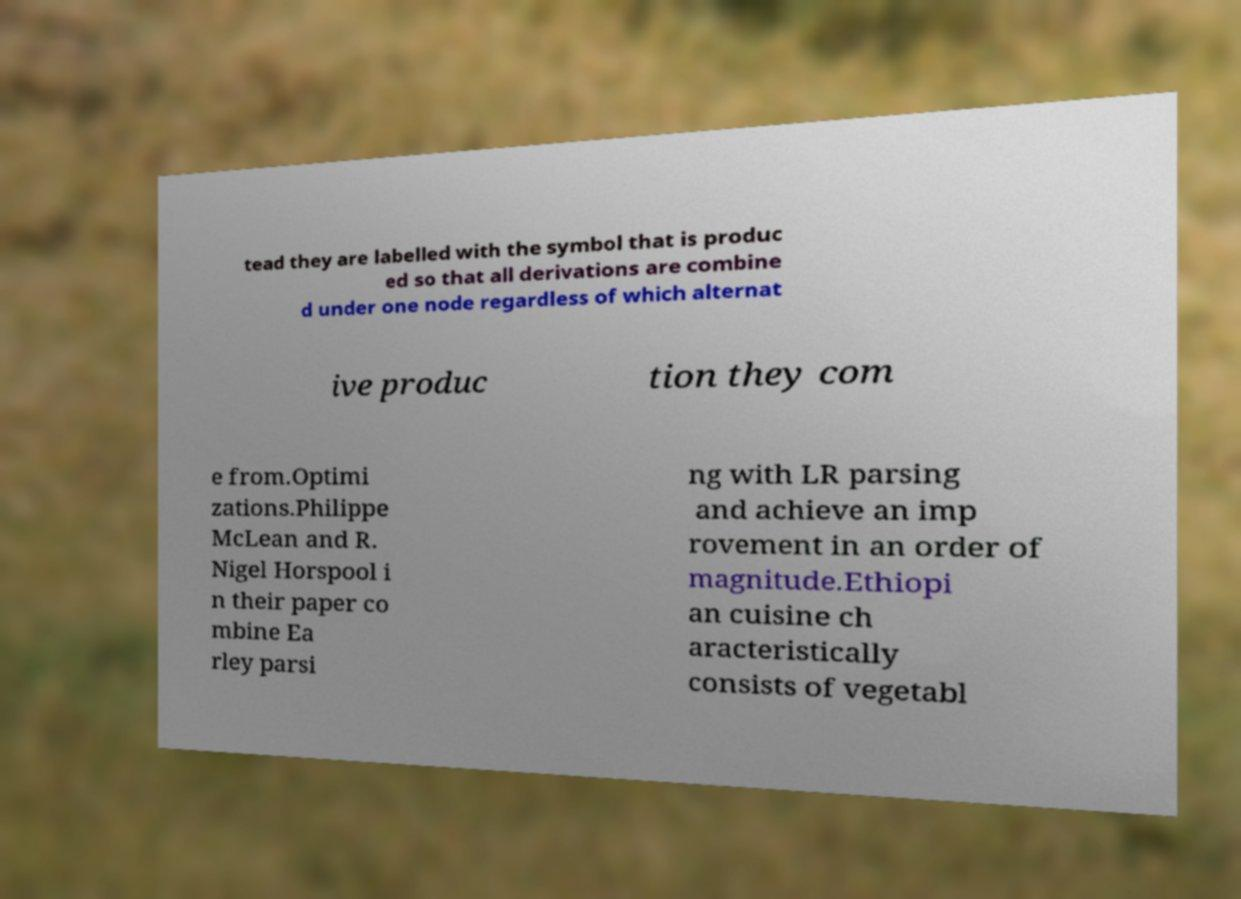I need the written content from this picture converted into text. Can you do that? tead they are labelled with the symbol that is produc ed so that all derivations are combine d under one node regardless of which alternat ive produc tion they com e from.Optimi zations.Philippe McLean and R. Nigel Horspool i n their paper co mbine Ea rley parsi ng with LR parsing and achieve an imp rovement in an order of magnitude.Ethiopi an cuisine ch aracteristically consists of vegetabl 